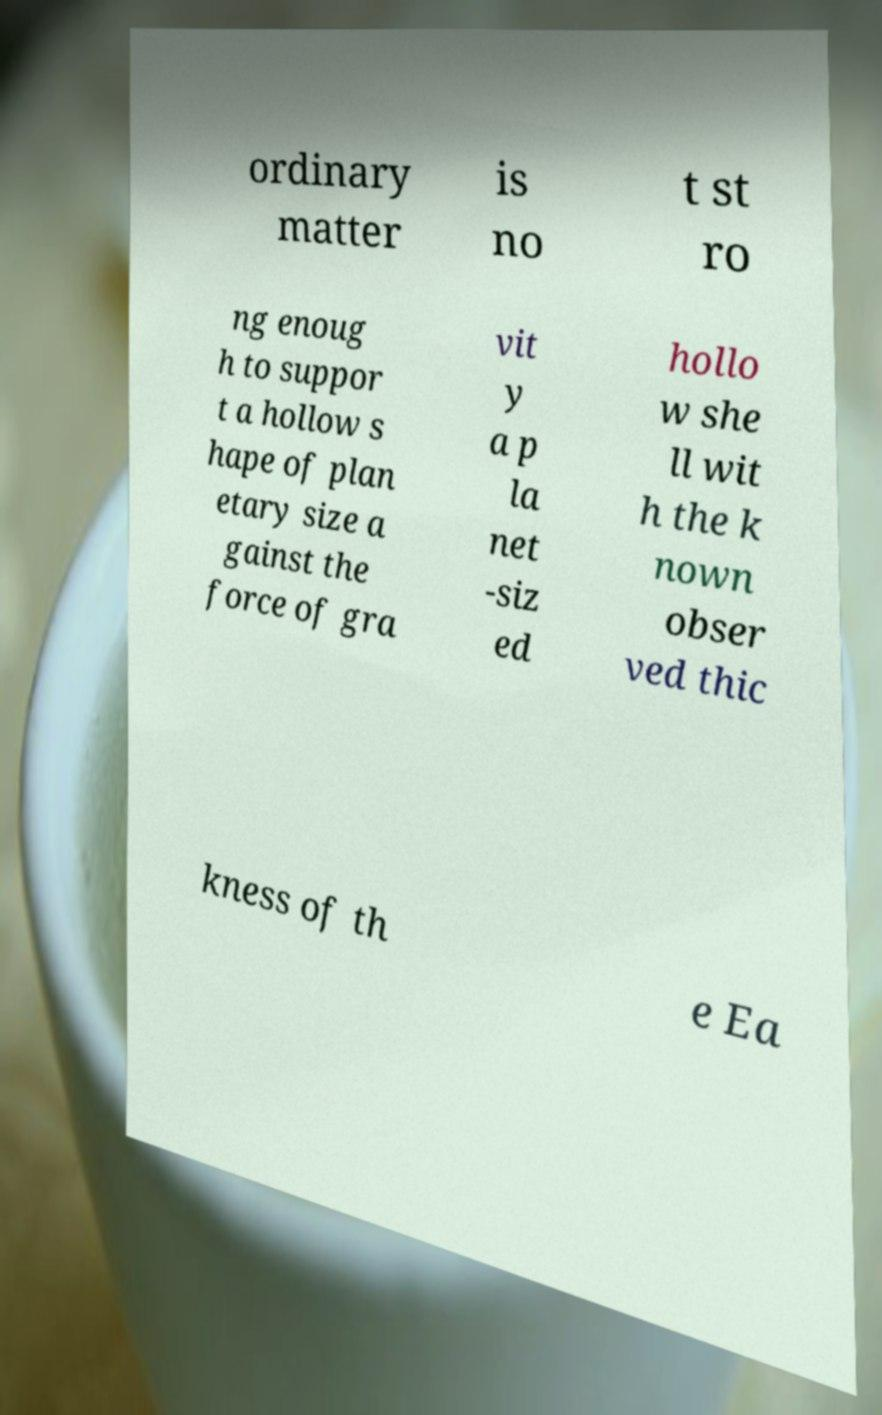Can you accurately transcribe the text from the provided image for me? ordinary matter is no t st ro ng enoug h to suppor t a hollow s hape of plan etary size a gainst the force of gra vit y a p la net -siz ed hollo w she ll wit h the k nown obser ved thic kness of th e Ea 